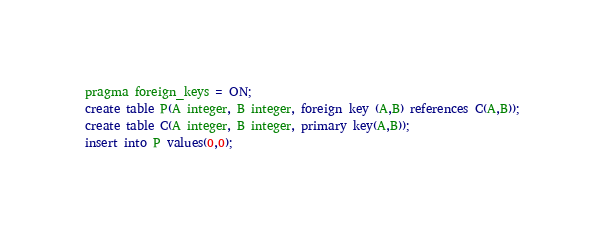<code> <loc_0><loc_0><loc_500><loc_500><_SQL_>pragma foreign_keys = ON;
create table P(A integer, B integer, foreign key (A,B) references C(A,B));
create table C(A integer, B integer, primary key(A,B));
insert into P values(0,0);

</code> 